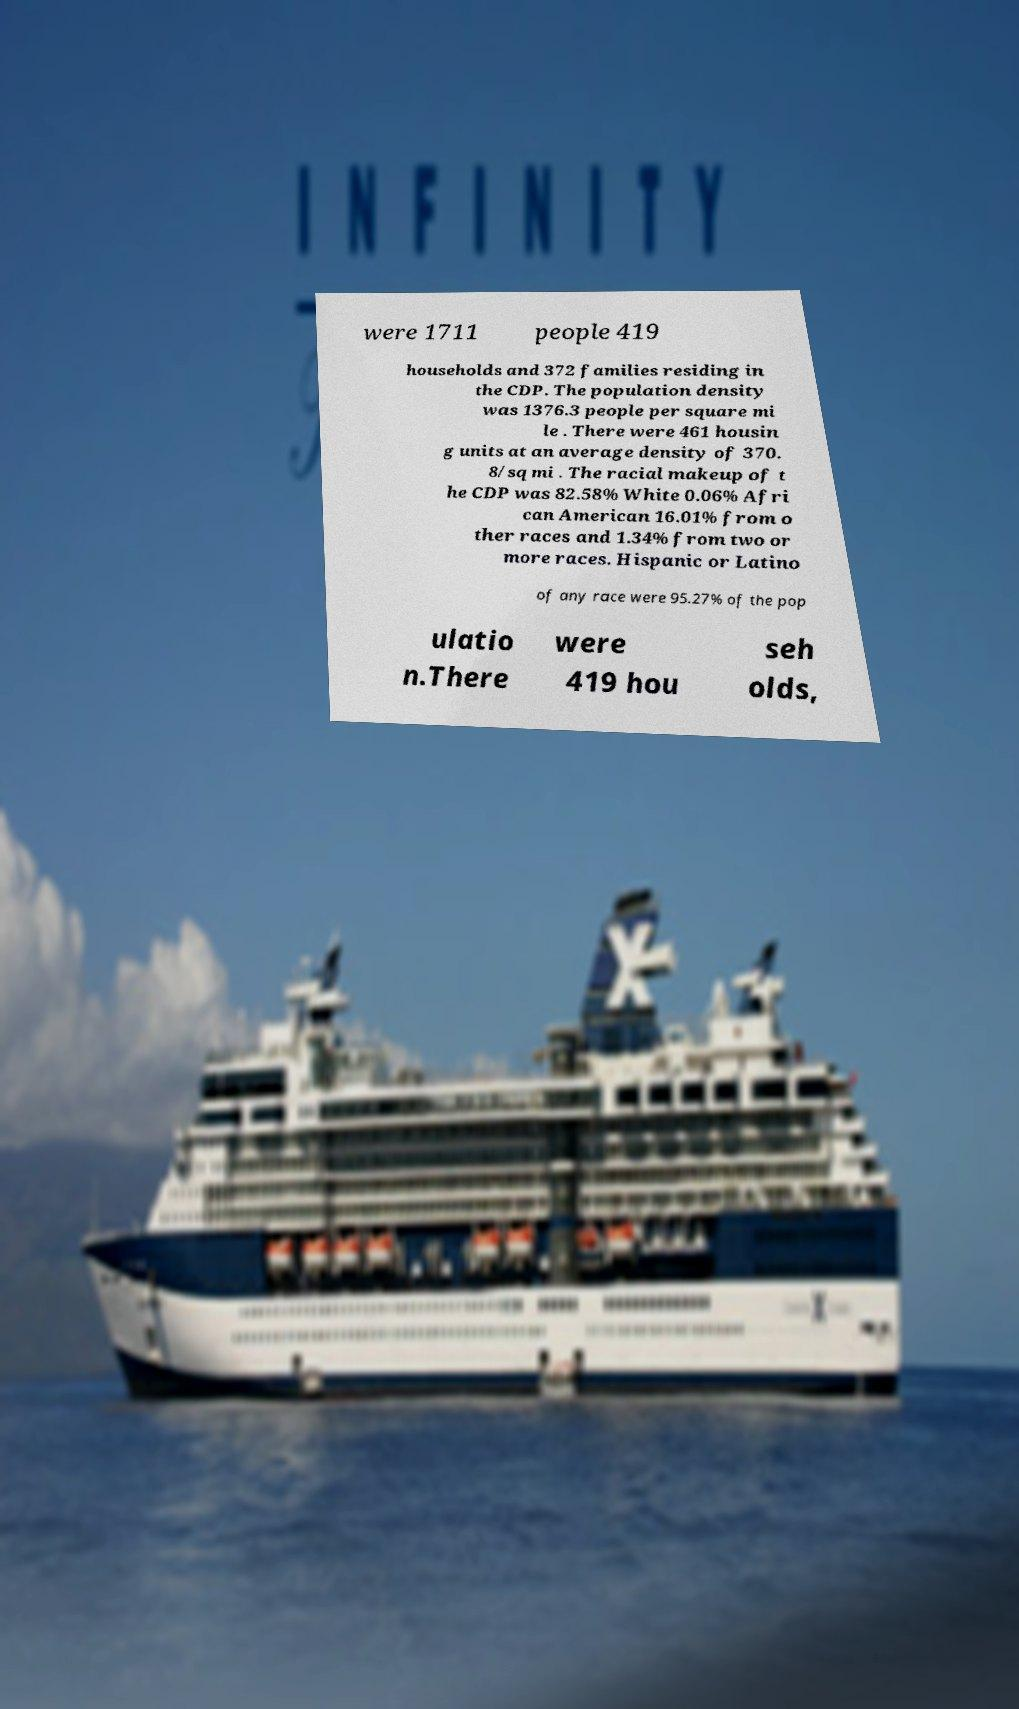Could you extract and type out the text from this image? were 1711 people 419 households and 372 families residing in the CDP. The population density was 1376.3 people per square mi le . There were 461 housin g units at an average density of 370. 8/sq mi . The racial makeup of t he CDP was 82.58% White 0.06% Afri can American 16.01% from o ther races and 1.34% from two or more races. Hispanic or Latino of any race were 95.27% of the pop ulatio n.There were 419 hou seh olds, 